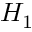Convert formula to latex. <formula><loc_0><loc_0><loc_500><loc_500>H _ { 1 }</formula> 